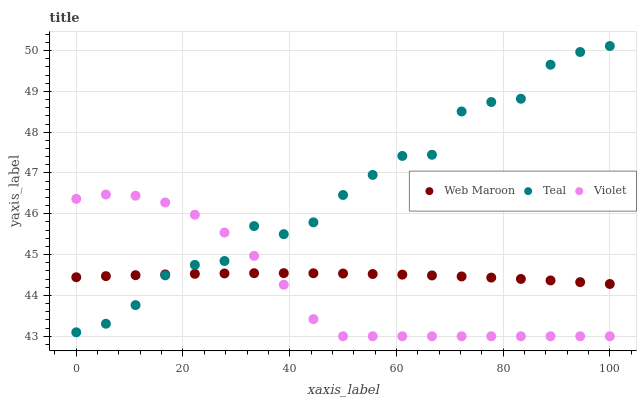Does Violet have the minimum area under the curve?
Answer yes or no. Yes. Does Teal have the maximum area under the curve?
Answer yes or no. Yes. Does Teal have the minimum area under the curve?
Answer yes or no. No. Does Violet have the maximum area under the curve?
Answer yes or no. No. Is Web Maroon the smoothest?
Answer yes or no. Yes. Is Teal the roughest?
Answer yes or no. Yes. Is Violet the smoothest?
Answer yes or no. No. Is Violet the roughest?
Answer yes or no. No. Does Violet have the lowest value?
Answer yes or no. Yes. Does Teal have the lowest value?
Answer yes or no. No. Does Teal have the highest value?
Answer yes or no. Yes. Does Violet have the highest value?
Answer yes or no. No. Does Violet intersect Teal?
Answer yes or no. Yes. Is Violet less than Teal?
Answer yes or no. No. Is Violet greater than Teal?
Answer yes or no. No. 